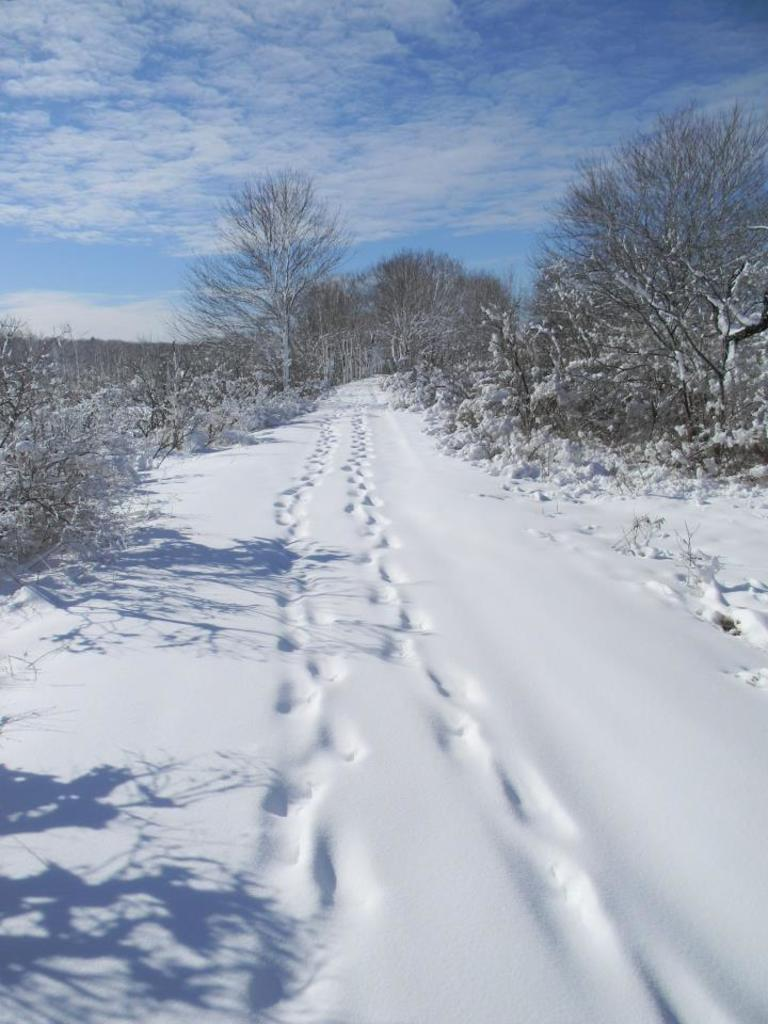What is covering the ground in the image? There is snow on the ground. What can be seen in the background of the image? There are bare trees in the background. What is visible in the sky in the image? Clouds are visible in the sky. Can you tell me how the engine is functioning in the image? There is no engine present in the image; it features snow on the ground, bare trees in the background, and clouds in the sky. What type of sea can be seen in the image? There is no sea present in the image; it features snow on the ground, bare trees in the background, and clouds in the sky. 